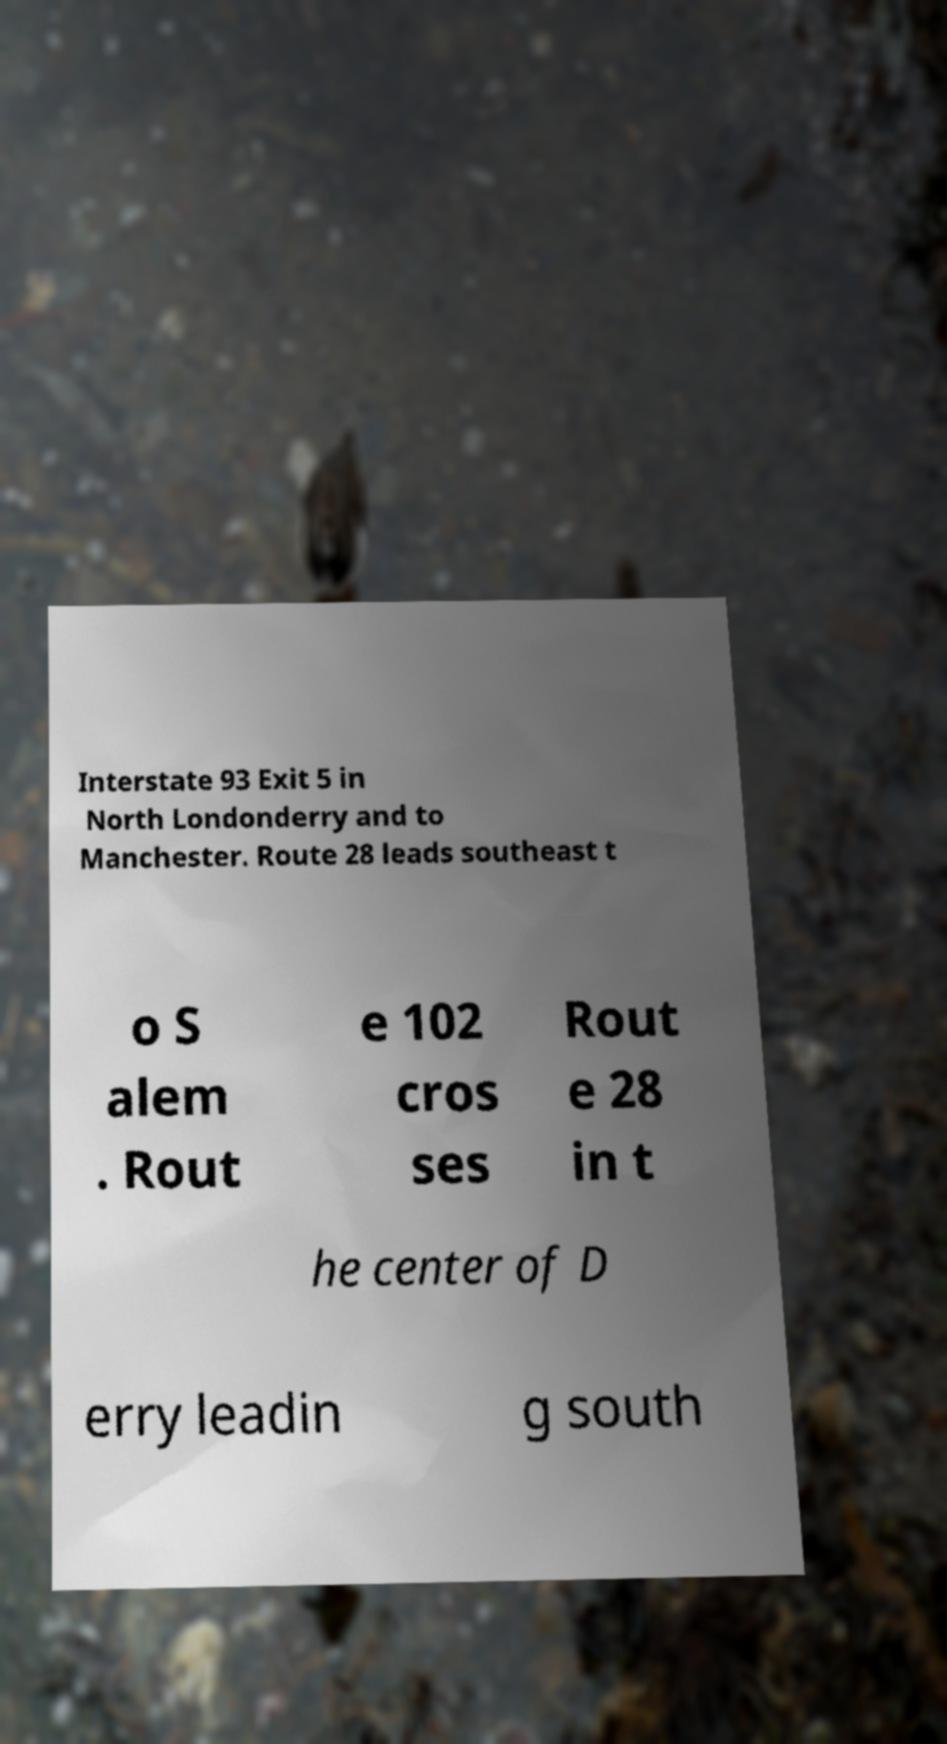I need the written content from this picture converted into text. Can you do that? Interstate 93 Exit 5 in North Londonderry and to Manchester. Route 28 leads southeast t o S alem . Rout e 102 cros ses Rout e 28 in t he center of D erry leadin g south 